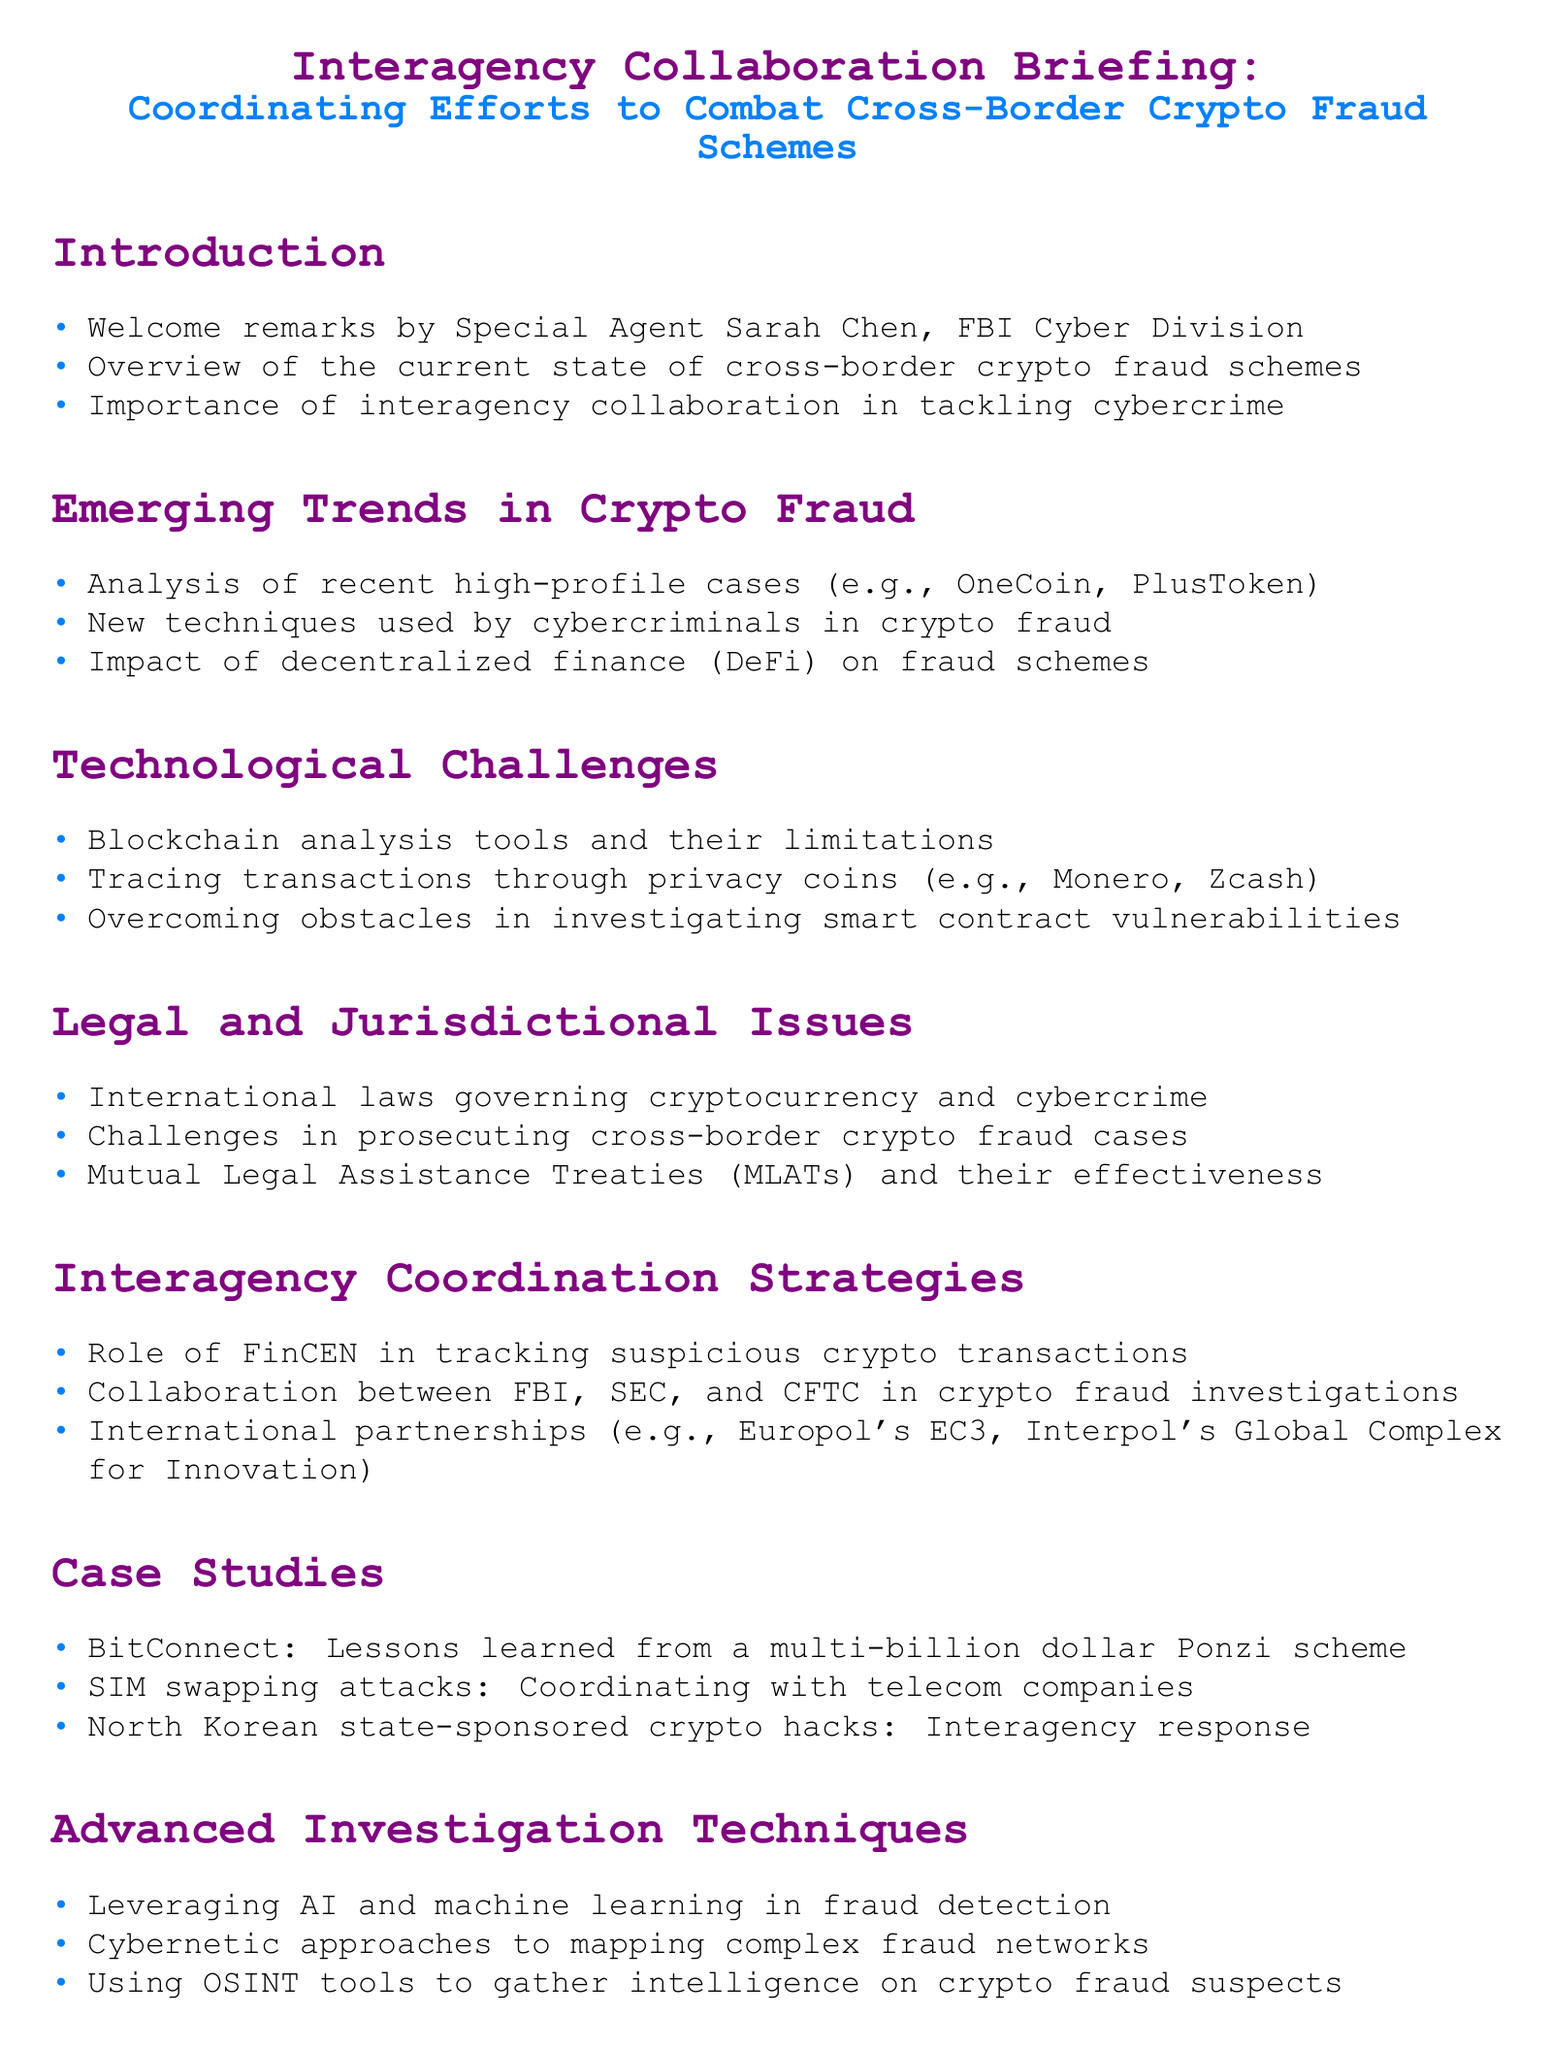What is the title of the briefing? The title summarizes the focus of the document on interagency collaboration to tackle crypto fraud.
Answer: Interagency Collaboration Briefing: Coordinating Efforts to Combat Cross-Border Crypto Fraud Schemes Who delivered the welcome remarks? This information is found in the introduction section of the document, specifying the speaker at the event.
Answer: Special Agent Sarah Chen What is one of the high-profile cases mentioned? The document lists recent cases to highlight examples of crypto fraud schemes.
Answer: OneCoin What role does FinCEN play in investigations? The document describes FinCEN's involvement in tracking transactions related to crypto fraud.
Answer: Tracking suspicious crypto transactions Which privacy coins are mentioned in challenges? The document highlights specific privacy coins that pose investigation challenges.
Answer: Monero, Zcash What technique is highlighted for fraud detection? The document discusses emerging technologies used in advanced investigation strategies.
Answer: Leveraging AI and machine learning What is a challenge in prosecuting crypto fraud cases? The document references legal hurdles encountered in pursuing cross-border crypto fraud.
Answer: Challenges in prosecuting cross-border crypto fraud cases What are MLATs? This term is explained in the context of their effectiveness in legal matters surrounding cryptocurrency.
Answer: Mutual Legal Assistance Treaties Which telecom-related attacks are discussed? The case studies section references specific methods of fraud involving telecommunications.
Answer: SIM swapping attacks What is a key focus of future preparedness? The document outlines important areas for agencies to prepare for upcoming threats in cryptocurrency.
Answer: Anticipating emerging threats in the crypto space 